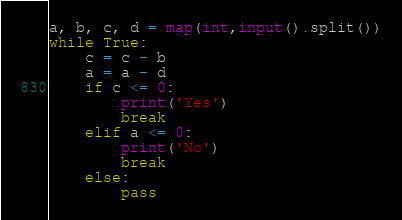<code> <loc_0><loc_0><loc_500><loc_500><_Python_>a, b, c, d = map(int,input().split())
while True:
    c = c - b
    a = a - d
    if c <= 0:
        print('Yes')
        break
    elif a <= 0:
        print('No')
        break
    else:
        pass</code> 